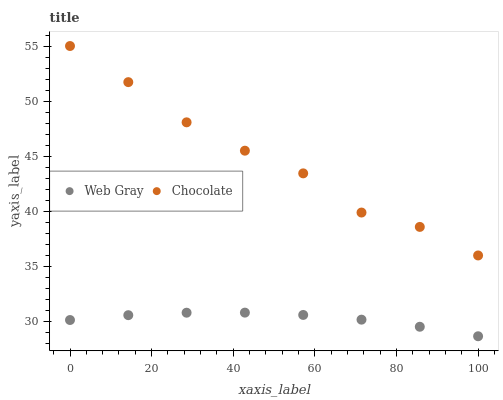Does Web Gray have the minimum area under the curve?
Answer yes or no. Yes. Does Chocolate have the maximum area under the curve?
Answer yes or no. Yes. Does Chocolate have the minimum area under the curve?
Answer yes or no. No. Is Web Gray the smoothest?
Answer yes or no. Yes. Is Chocolate the roughest?
Answer yes or no. Yes. Is Chocolate the smoothest?
Answer yes or no. No. Does Web Gray have the lowest value?
Answer yes or no. Yes. Does Chocolate have the lowest value?
Answer yes or no. No. Does Chocolate have the highest value?
Answer yes or no. Yes. Is Web Gray less than Chocolate?
Answer yes or no. Yes. Is Chocolate greater than Web Gray?
Answer yes or no. Yes. Does Web Gray intersect Chocolate?
Answer yes or no. No. 